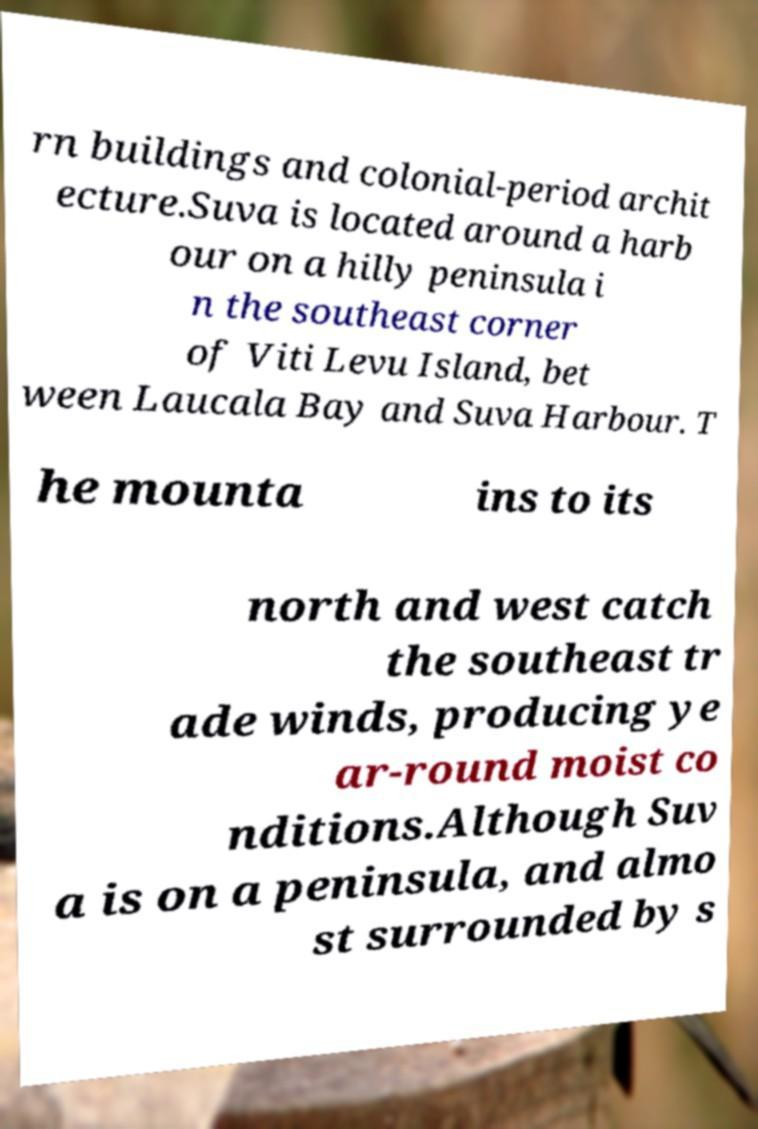I need the written content from this picture converted into text. Can you do that? rn buildings and colonial-period archit ecture.Suva is located around a harb our on a hilly peninsula i n the southeast corner of Viti Levu Island, bet ween Laucala Bay and Suva Harbour. T he mounta ins to its north and west catch the southeast tr ade winds, producing ye ar-round moist co nditions.Although Suv a is on a peninsula, and almo st surrounded by s 